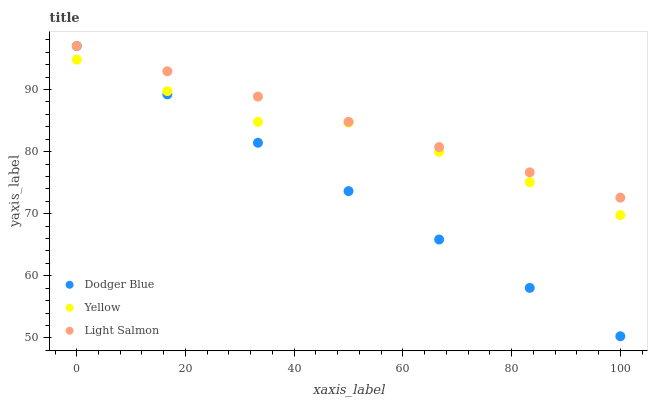Does Dodger Blue have the minimum area under the curve?
Answer yes or no. Yes. Does Light Salmon have the maximum area under the curve?
Answer yes or no. Yes. Does Yellow have the minimum area under the curve?
Answer yes or no. No. Does Yellow have the maximum area under the curve?
Answer yes or no. No. Is Light Salmon the smoothest?
Answer yes or no. Yes. Is Yellow the roughest?
Answer yes or no. Yes. Is Yellow the smoothest?
Answer yes or no. No. Is Dodger Blue the roughest?
Answer yes or no. No. Does Dodger Blue have the lowest value?
Answer yes or no. Yes. Does Yellow have the lowest value?
Answer yes or no. No. Does Dodger Blue have the highest value?
Answer yes or no. Yes. Does Yellow have the highest value?
Answer yes or no. No. Is Yellow less than Light Salmon?
Answer yes or no. Yes. Is Light Salmon greater than Yellow?
Answer yes or no. Yes. Does Yellow intersect Dodger Blue?
Answer yes or no. Yes. Is Yellow less than Dodger Blue?
Answer yes or no. No. Is Yellow greater than Dodger Blue?
Answer yes or no. No. Does Yellow intersect Light Salmon?
Answer yes or no. No. 